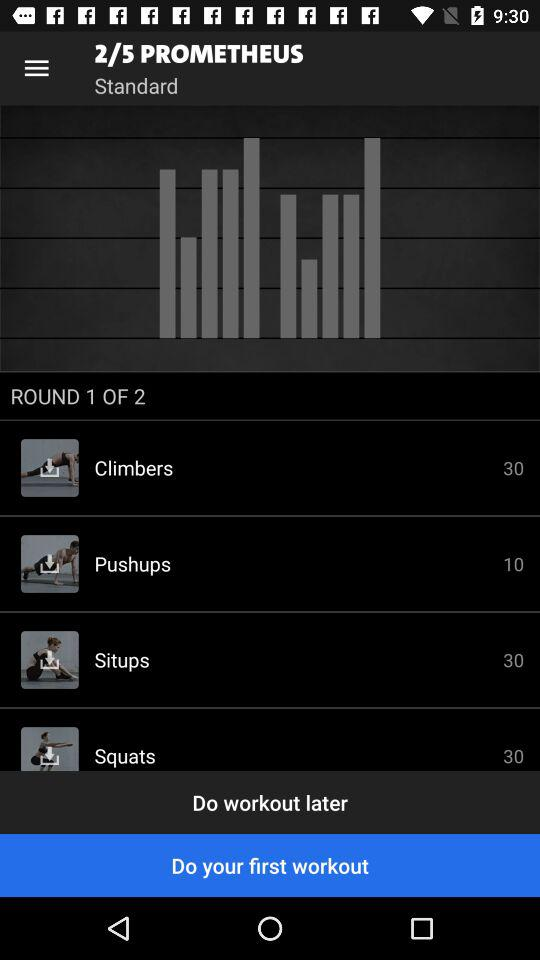Among the exercises listed, which one is recommended for lower body strength? For strengthening the lower body, the exercise listed as 'squats' with 30 repetitions is highly recommended. Squats target the quadriceps, hamstrings, and glutes, making it a powerful exercise for building lower body strength. 